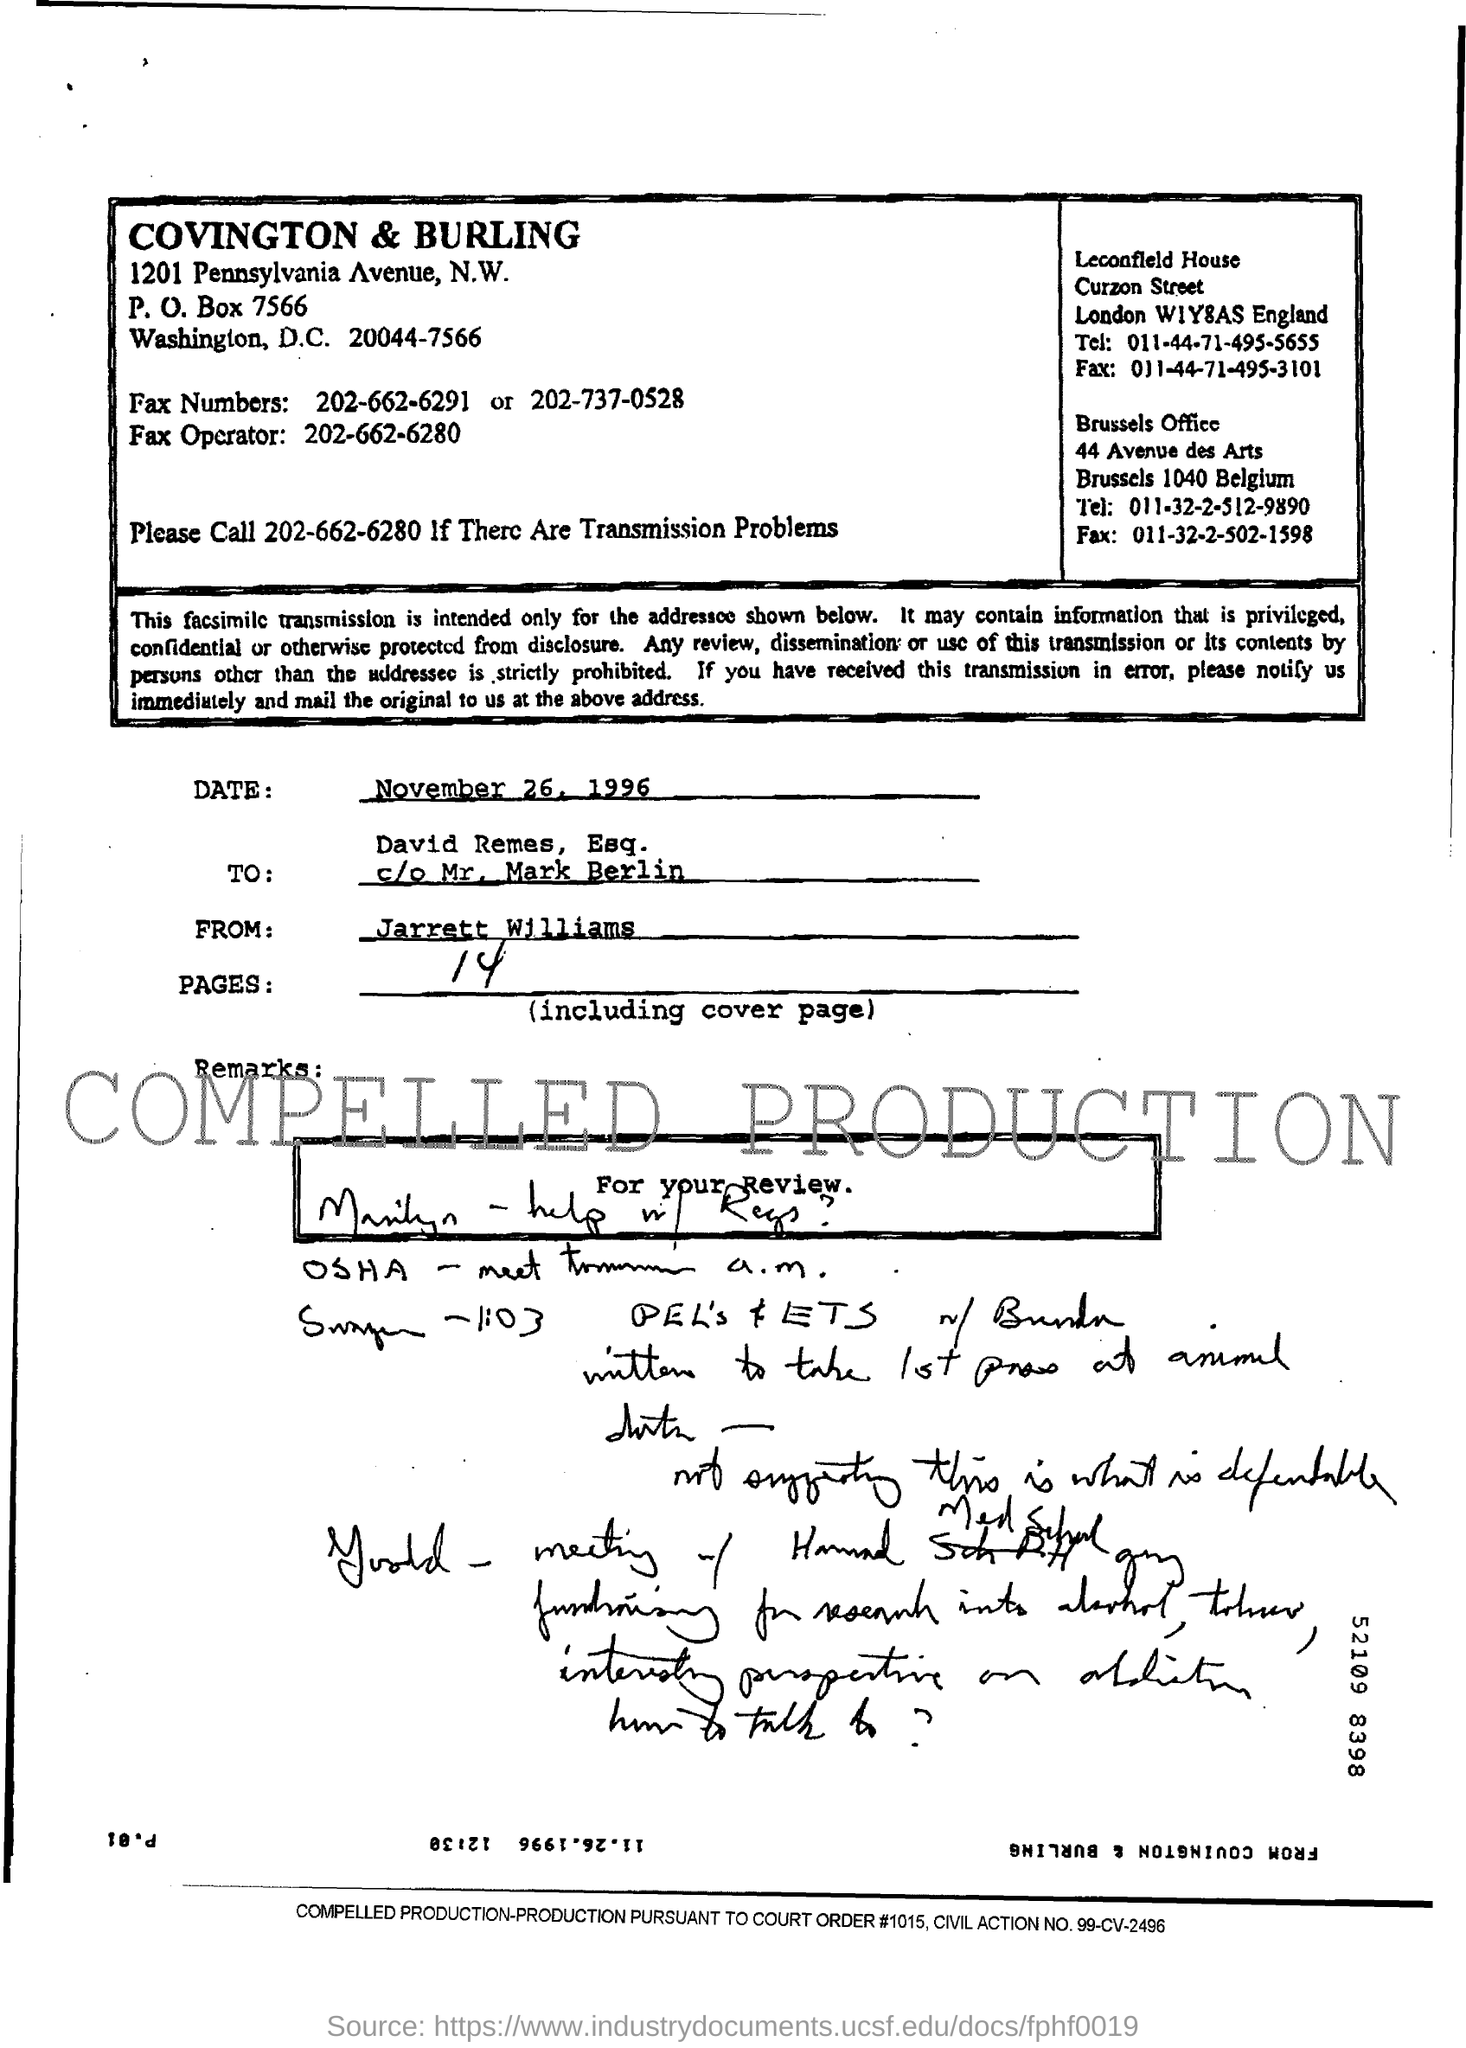Who is the sender of the Fax?
Offer a very short reply. Jarrett Williams. What is the date of fax transmission?
Offer a very short reply. November 26, 1996. What is the no of pages in the fax including cover page?
Give a very brief answer. 14. Who is the receiver of the fax?
Your response must be concise. David Remes. What is the fax operator no mentioned in the document?
Your answer should be very brief. 202-662-6280. 